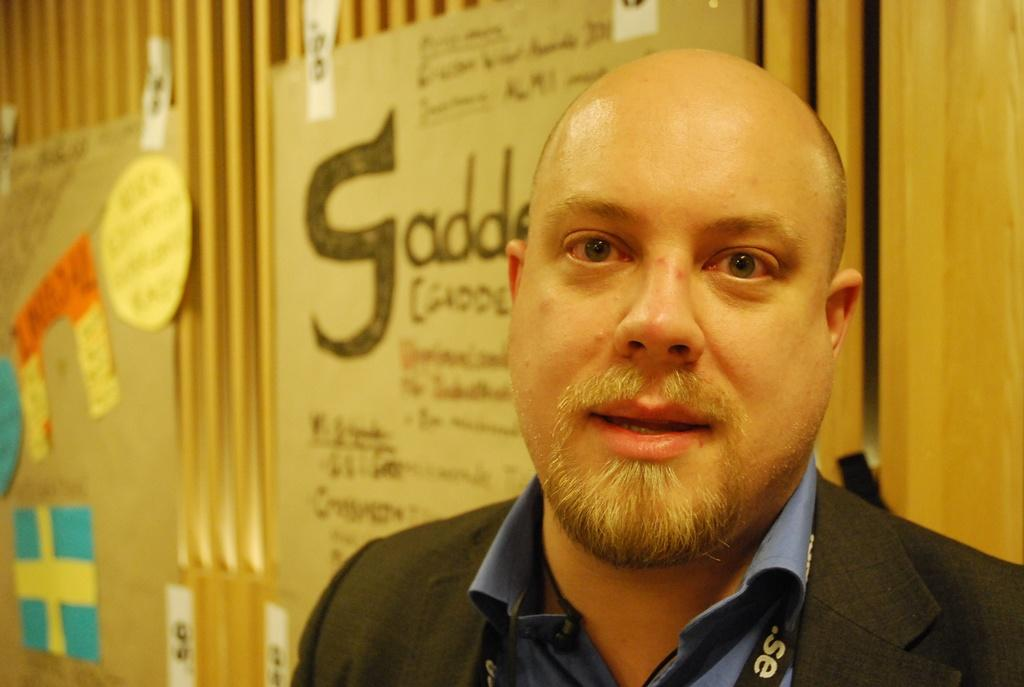Who is present in the image? There is a man in the image. What is the man wearing in the image? The man is wearing a tag in the image. What can be seen in the background of the image? There are posters in the background of the image. What type of vegetable is the man holding in the image? There is no vegetable present in the image; the man is wearing a tag and standing in front of posters. 